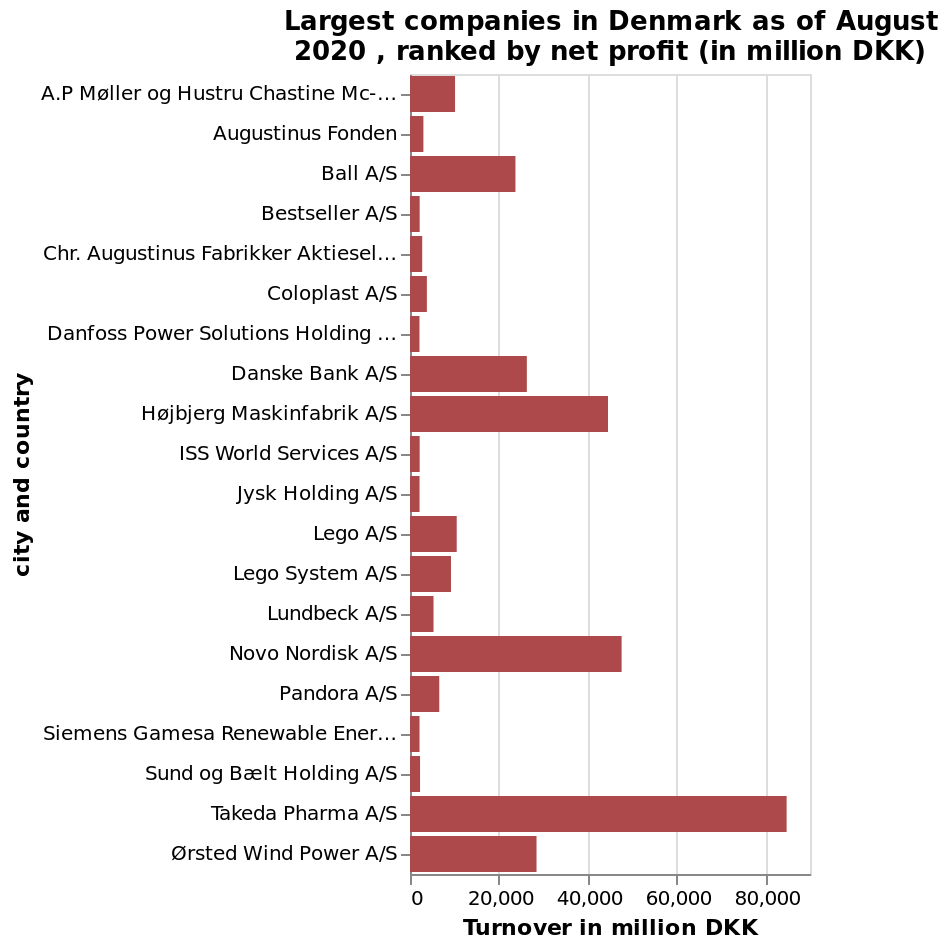<image>
What is the title of the bar chart and what is it depicting?  The title of the bar chart is "Largest companies in Denmark as of August 2020, ranked by net profit (in million DKK)". It is depicting the net profit of the companies. In what year did Takeda Pharma achieve the highest net income among companies in Denmark? 2020. 